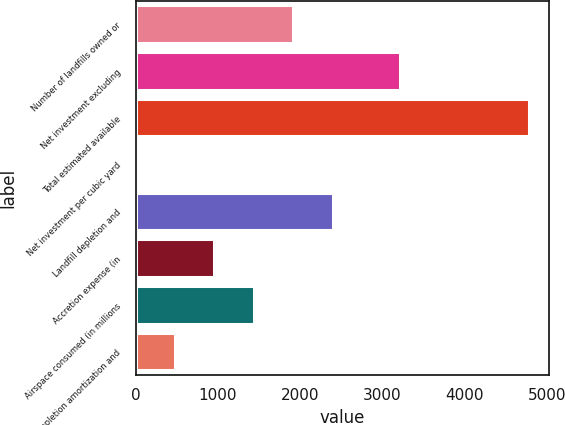<chart> <loc_0><loc_0><loc_500><loc_500><bar_chart><fcel>Number of landfills owned or<fcel>Net investment excluding<fcel>Total estimated available<fcel>Net investment per cubic yard<fcel>Landfill depletion and<fcel>Accretion expense (in<fcel>Airspace consumed (in millions<fcel>Depletion amortization and<nl><fcel>1915.71<fcel>3214.9<fcel>4788.3<fcel>0.67<fcel>2394.47<fcel>958.19<fcel>1436.95<fcel>479.43<nl></chart> 